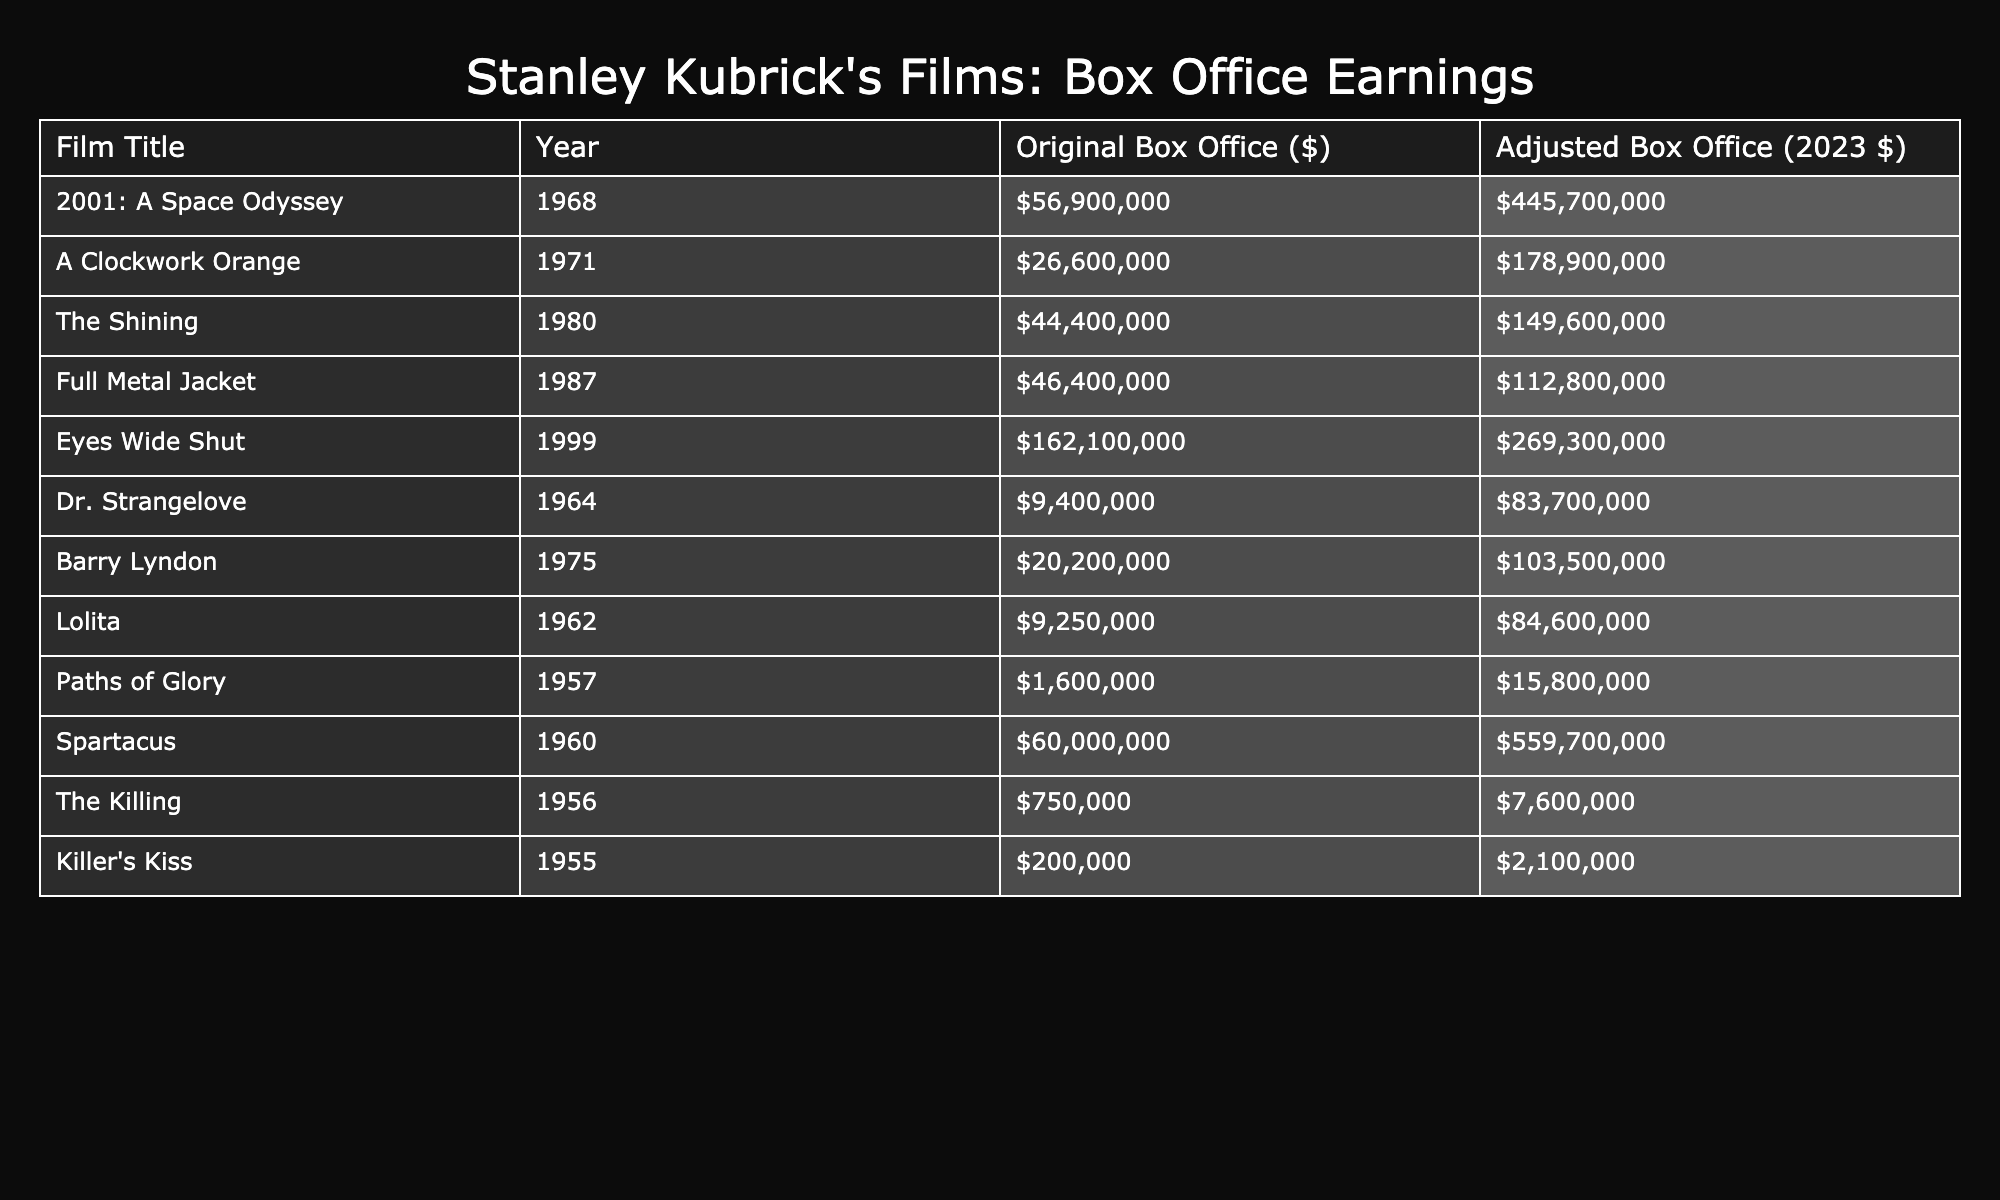What is the highest adjusted box office earning among Stanley Kubrick's films? According to the table, "2001: A Space Odyssey" has the highest adjusted box office earning of $445,700,000.
Answer: $445,700,000 Which film was released most recently and what was its adjusted box office? The most recent film is "Eyes Wide Shut," released in 1999, with an adjusted box office of $269,300,000.
Answer: $269,300,000 What is the total adjusted box office of Kubrick's films from the 1960s? The films from the 1960s are "Dr. Strangelove" (83,700,000), "Spartacus" (559,700,000), and "Lolita" (84,600,000). Adding these gives 83,700,000 + 559,700,000 + 84,600,000 = 728,000,000.
Answer: $728,000,000 Are there any films by Stanley Kubrick that have an adjusted box office earning below $100 million? Yes, "Full Metal Jacket" ($112,800,000), "The Shining" ($149,600,000), "A Clockwork Orange" ($178,900,000), and "Barry Lyndon" ($103,500,000) have adjusted earnings below $200 million, but "Killer's Kiss" ($2,100,000) and "The Killing" ($7,600,000) are below $10 million.
Answer: Yes What is the difference in the original box office earnings between "The Shining" and "A Clockwork Orange"? "The Shining" made $44,400,000 while "A Clockwork Orange" made $26,600,000. The difference is $44,400,000 - $26,600,000 = $17,800,000.
Answer: $17,800,000 If we average the adjusted box office earnings of the films from the 1970s, what would it be? The films are "Barry Lyndon" ($103,500,000) and "A Clockwork Orange" ($178,900,000). The sum is $103,500,000 + $178,900,000 = $282,400,000. There are 2 films, so the average is $282,400,000 / 2 = $141,200,000.
Answer: $141,200,000 Which film has the lowest original box office earnings and what were they? The film "The Killing" has the lowest original box office earnings of $750,000.
Answer: $750,000 What percentage of the highest adjusted box office earning does "Eyes Wide Shut" represent? The highest adjusted box office is $445,700,000 from "2001: A Space Odyssey." "Eyes Wide Shut" has $269,300,000. The percentage is (269,300,000 / 445,700,000) * 100 ≈ 60.4%.
Answer: 60.4% 